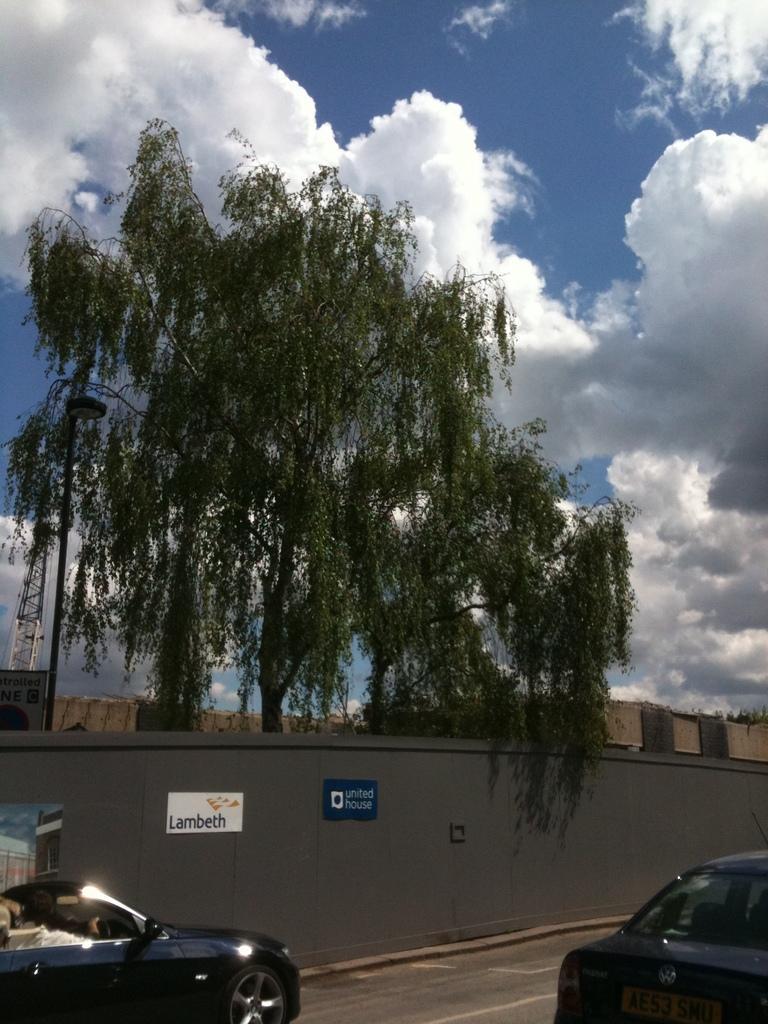In one or two sentences, can you explain what this image depicts? This is an outside view. At the bottom there are two cars on the road. Beside the road there is a wall on which few boards are attached. Behind the wall there is a tree and a building. At the top of the image I can see the sky and clouds. 